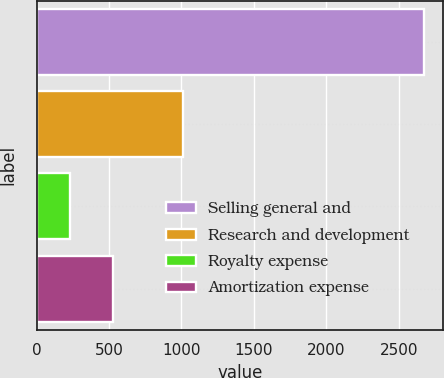Convert chart to OTSL. <chart><loc_0><loc_0><loc_500><loc_500><bar_chart><fcel>Selling general and<fcel>Research and development<fcel>Royalty expense<fcel>Amortization expense<nl><fcel>2675<fcel>1008<fcel>231<fcel>530<nl></chart> 